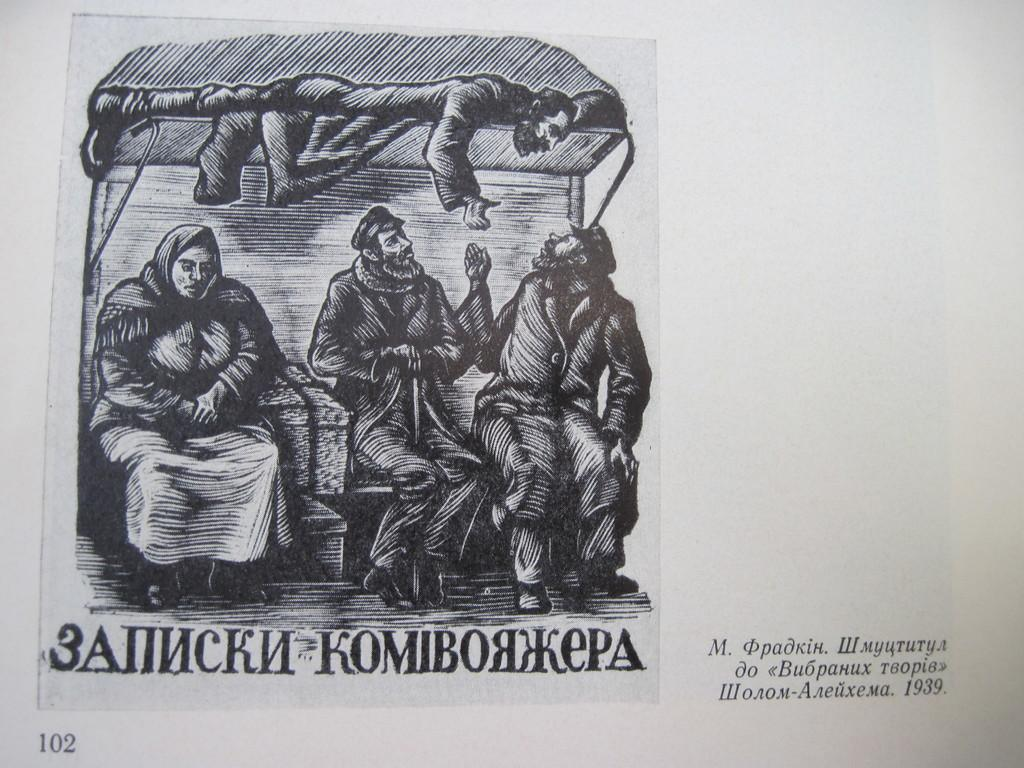What is depicted on the paper in the image? The paper contains a sketch of some people. What else can be found on the paper besides the sketch? There is text on the paper. What type of structure is the lawyer standing in front of in the image? There is no lawyer or structure present in the image; it only contains a sketch of some people and text on a paper. 